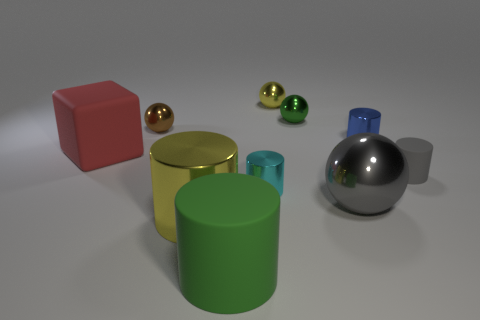Do the small cyan shiny object and the large green object have the same shape?
Keep it short and to the point. Yes. What is the color of the large ball?
Ensure brevity in your answer.  Gray. The gray cylinder that is the same material as the large block is what size?
Your response must be concise. Small. What is the color of the tiny thing that is made of the same material as the large red thing?
Offer a very short reply. Gray. Are there any objects that have the same size as the blue cylinder?
Give a very brief answer. Yes. What is the material of the gray thing that is the same shape as the small cyan shiny thing?
Provide a short and direct response. Rubber. There is a yellow object that is the same size as the brown shiny thing; what is its shape?
Your answer should be very brief. Sphere. Are there any large objects of the same shape as the tiny matte thing?
Give a very brief answer. Yes. What is the shape of the yellow shiny object that is in front of the cylinder behind the large rubber cube?
Your answer should be very brief. Cylinder. What is the shape of the green matte thing?
Make the answer very short. Cylinder. 